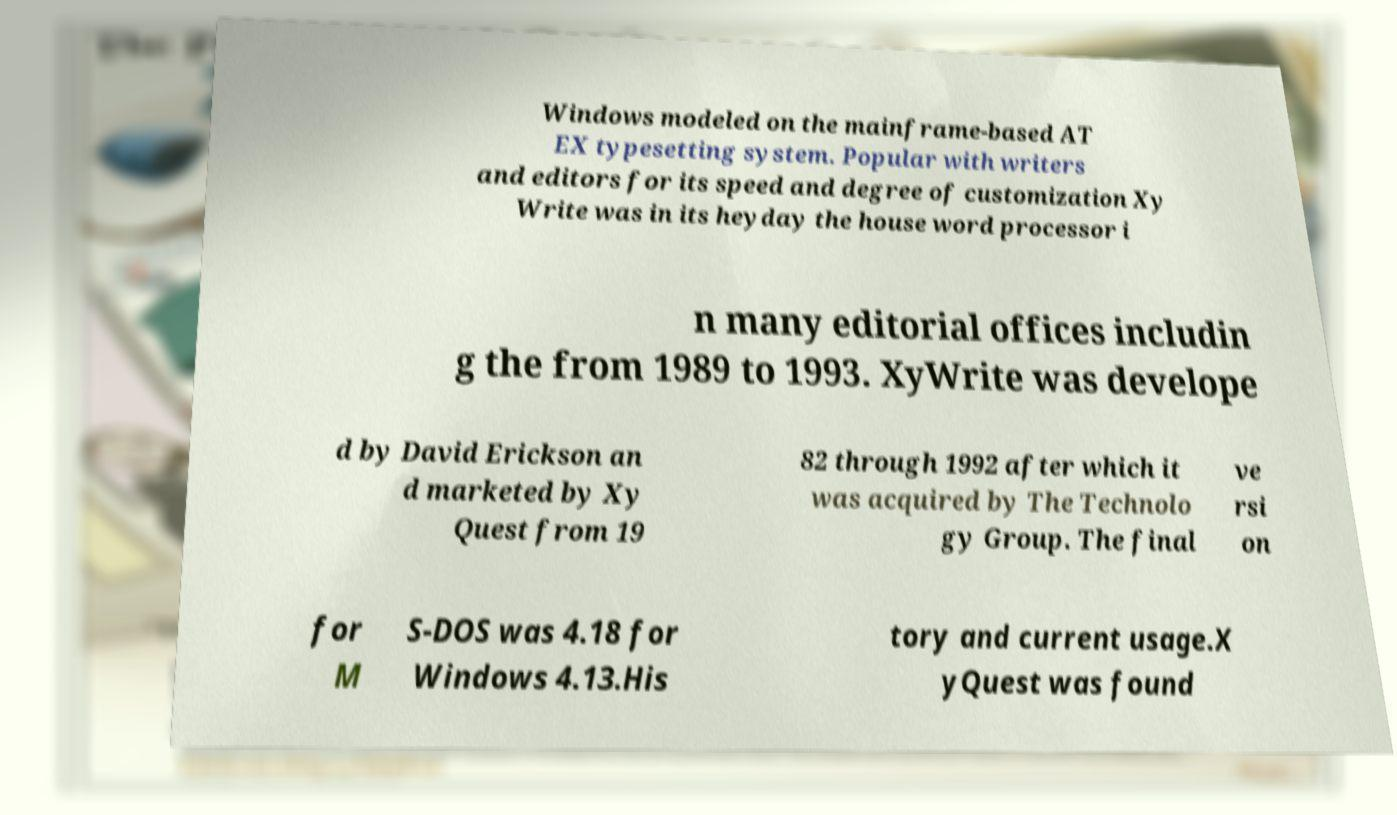Can you accurately transcribe the text from the provided image for me? Windows modeled on the mainframe-based AT EX typesetting system. Popular with writers and editors for its speed and degree of customization Xy Write was in its heyday the house word processor i n many editorial offices includin g the from 1989 to 1993. XyWrite was develope d by David Erickson an d marketed by Xy Quest from 19 82 through 1992 after which it was acquired by The Technolo gy Group. The final ve rsi on for M S-DOS was 4.18 for Windows 4.13.His tory and current usage.X yQuest was found 